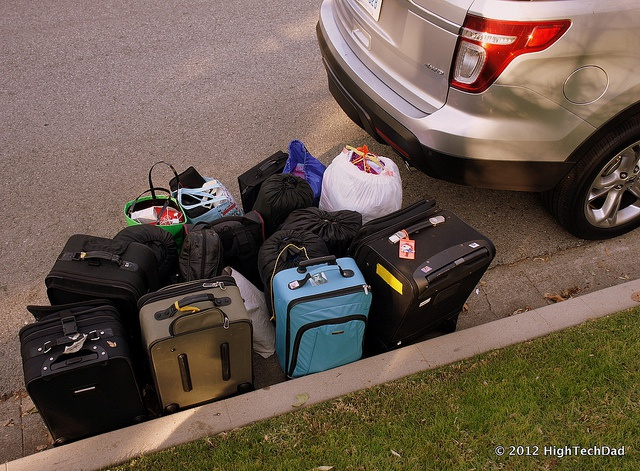Describe the objects in this image and their specific colors. I can see car in gray, black, darkgray, and tan tones, suitcase in gray, black, and maroon tones, suitcase in gray, black, and darkgray tones, suitcase in gray, black, and maroon tones, and suitcase in gray, teal, and black tones in this image. 